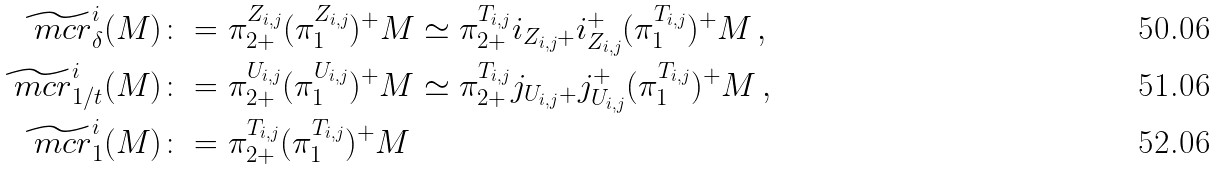Convert formula to latex. <formula><loc_0><loc_0><loc_500><loc_500>\widetilde { \ m c r } ^ { i } _ { \delta } ( M ) & \colon = \pi _ { 2 + } ^ { Z _ { i , j } } ( \pi _ { 1 } ^ { Z _ { i , j } } ) ^ { + } M \simeq \pi _ { 2 + } ^ { T _ { i , j } } i _ { Z _ { i , j } + } i _ { Z _ { i , j } } ^ { + } ( \pi _ { 1 } ^ { T _ { i , j } } ) ^ { + } M \, , \\ \widetilde { \ m c r } ^ { i } _ { 1 / t } ( M ) & \colon = \pi _ { 2 + } ^ { U _ { i , j } } ( \pi _ { 1 } ^ { U _ { i , j } } ) ^ { + } M \simeq \pi _ { 2 + } ^ { T _ { i , j } } j _ { U _ { i , j } + } j _ { U _ { i , j } } ^ { + } ( \pi _ { 1 } ^ { T _ { i , j } } ) ^ { + } M \, , \\ \widetilde { \ m c r } ^ { i } _ { 1 } ( M ) & \colon = \pi _ { 2 + } ^ { T _ { i , j } } ( \pi _ { 1 } ^ { T _ { i , j } } ) ^ { + } M</formula> 